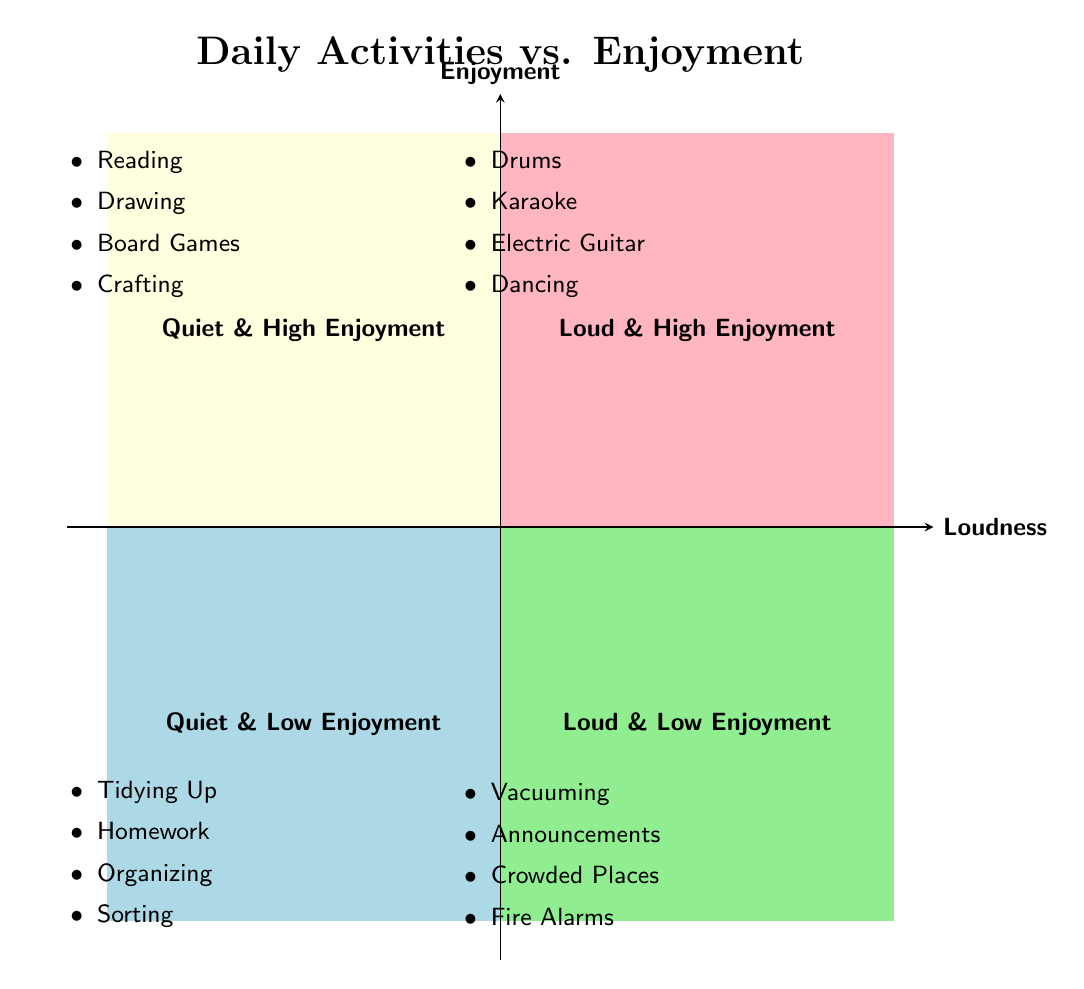What activities are found in the Quiet & High Enjoyment quadrant? The Quiet & High Enjoyment quadrant contains activities such as Reading Picture Books, Drawing and Coloring, Playing Board Games, and Crafting with Clay. These activities are specifically listed in that quadrant.
Answer: Reading Picture Books, Drawing and Coloring, Playing Board Games, Crafting with Clay How many activities are categorized as Loud & Low Enjoyment? The Loud & Low Enjoyment quadrant lists four activities: Loud Chores (Vacuuming), Public Announcements, Loud Crowded Places, and Fire Alarms. Counting these gives a total of four activities.
Answer: 4 Which Loud activity has the highest enjoyment? In the Loud & High Enjoyment quadrant, the activities include Playing Drums, Singing with Karaoke Machine, Playing Electric Guitar, and Dancing to Music. All these activities are classified as high enjoyment, but the question asks for the one with the highest enjoyment. Typically, there's not a ranking in this context, so we can choose any; I'll say Singing with Karaoke Machine.
Answer: Singing with Karaoke Machine Contrast the Quiet & Low Enjoyment activities with the Loud & High Enjoyment activities. The Quiet & Low Enjoyment quadrant contains activities that people generally find less enjoyable, such as Tidying Up Toys and Silent Homework, while the Loud & High Enjoyment quadrant includes activities like Playing Drums and Dancing, which are enjoyable. This highlights a clear distinction between less favored quiet tasks and highly favored loud tasks.
Answer: Tidying Up Toys vs. Playing Drums What is the overall theme of the diagram? The diagram illustrates the relationship between daily activities categorized by their loudness (Quiet vs. Loud) and the level of enjoyment (High vs. Low), effectively denoting how certain activities resonate with personal enjoyment in different sound environments.
Answer: Activities and Enjoyment Level How many Quiet activities are there in total? There are two sets of Quiet activities: High Enjoyment and Low Enjoyment. Each set has four activities listed, giving us a total of eight Quiet activities overall when both sets are combined.
Answer: 8 